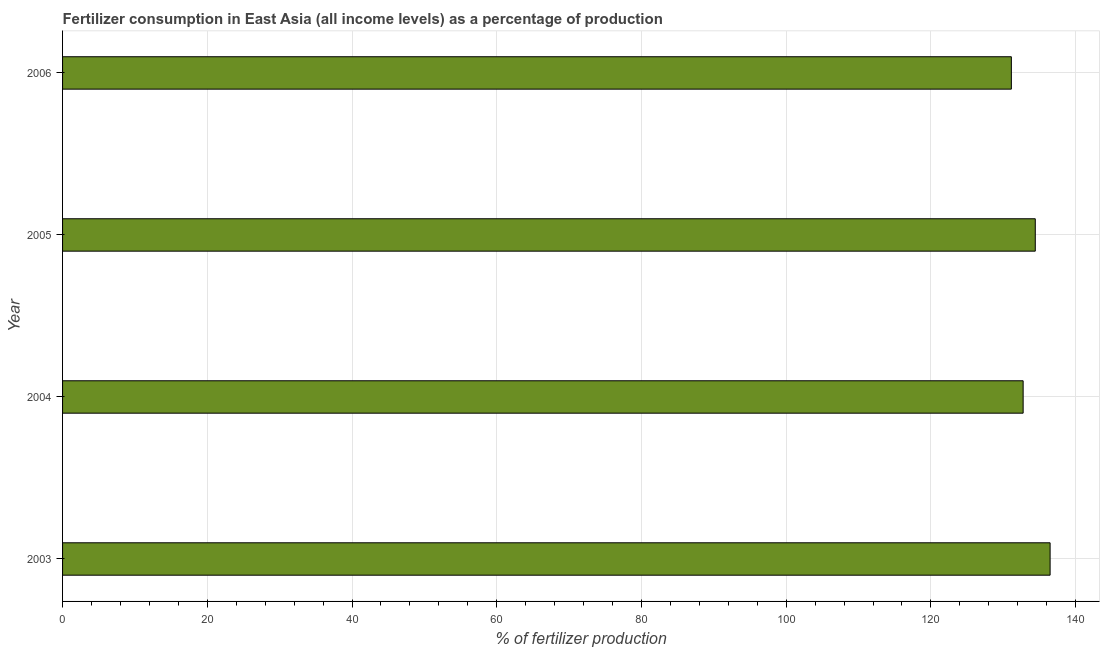Does the graph contain grids?
Make the answer very short. Yes. What is the title of the graph?
Offer a very short reply. Fertilizer consumption in East Asia (all income levels) as a percentage of production. What is the label or title of the X-axis?
Your answer should be compact. % of fertilizer production. What is the label or title of the Y-axis?
Ensure brevity in your answer.  Year. What is the amount of fertilizer consumption in 2006?
Offer a terse response. 131.12. Across all years, what is the maximum amount of fertilizer consumption?
Make the answer very short. 136.48. Across all years, what is the minimum amount of fertilizer consumption?
Your answer should be compact. 131.12. In which year was the amount of fertilizer consumption maximum?
Give a very brief answer. 2003. What is the sum of the amount of fertilizer consumption?
Ensure brevity in your answer.  534.77. What is the difference between the amount of fertilizer consumption in 2005 and 2006?
Give a very brief answer. 3.3. What is the average amount of fertilizer consumption per year?
Provide a succinct answer. 133.69. What is the median amount of fertilizer consumption?
Keep it short and to the point. 133.59. In how many years, is the amount of fertilizer consumption greater than 12 %?
Make the answer very short. 4. Is the amount of fertilizer consumption in 2003 less than that in 2006?
Offer a very short reply. No. What is the difference between the highest and the second highest amount of fertilizer consumption?
Provide a succinct answer. 2.05. What is the difference between the highest and the lowest amount of fertilizer consumption?
Your answer should be very brief. 5.35. What is the difference between two consecutive major ticks on the X-axis?
Keep it short and to the point. 20. What is the % of fertilizer production in 2003?
Provide a succinct answer. 136.48. What is the % of fertilizer production in 2004?
Make the answer very short. 132.75. What is the % of fertilizer production of 2005?
Your answer should be compact. 134.43. What is the % of fertilizer production in 2006?
Make the answer very short. 131.12. What is the difference between the % of fertilizer production in 2003 and 2004?
Provide a short and direct response. 3.73. What is the difference between the % of fertilizer production in 2003 and 2005?
Your answer should be compact. 2.05. What is the difference between the % of fertilizer production in 2003 and 2006?
Provide a short and direct response. 5.36. What is the difference between the % of fertilizer production in 2004 and 2005?
Your answer should be very brief. -1.68. What is the difference between the % of fertilizer production in 2004 and 2006?
Your response must be concise. 1.63. What is the difference between the % of fertilizer production in 2005 and 2006?
Offer a very short reply. 3.3. What is the ratio of the % of fertilizer production in 2003 to that in 2004?
Offer a terse response. 1.03. What is the ratio of the % of fertilizer production in 2003 to that in 2005?
Give a very brief answer. 1.01. What is the ratio of the % of fertilizer production in 2003 to that in 2006?
Your response must be concise. 1.04. What is the ratio of the % of fertilizer production in 2005 to that in 2006?
Ensure brevity in your answer.  1.02. 